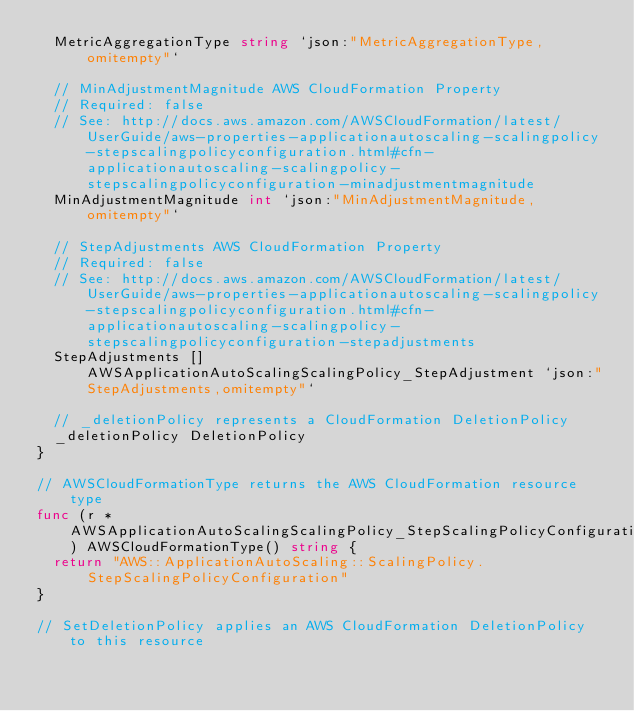<code> <loc_0><loc_0><loc_500><loc_500><_Go_>	MetricAggregationType string `json:"MetricAggregationType,omitempty"`

	// MinAdjustmentMagnitude AWS CloudFormation Property
	// Required: false
	// See: http://docs.aws.amazon.com/AWSCloudFormation/latest/UserGuide/aws-properties-applicationautoscaling-scalingpolicy-stepscalingpolicyconfiguration.html#cfn-applicationautoscaling-scalingpolicy-stepscalingpolicyconfiguration-minadjustmentmagnitude
	MinAdjustmentMagnitude int `json:"MinAdjustmentMagnitude,omitempty"`

	// StepAdjustments AWS CloudFormation Property
	// Required: false
	// See: http://docs.aws.amazon.com/AWSCloudFormation/latest/UserGuide/aws-properties-applicationautoscaling-scalingpolicy-stepscalingpolicyconfiguration.html#cfn-applicationautoscaling-scalingpolicy-stepscalingpolicyconfiguration-stepadjustments
	StepAdjustments []AWSApplicationAutoScalingScalingPolicy_StepAdjustment `json:"StepAdjustments,omitempty"`

	// _deletionPolicy represents a CloudFormation DeletionPolicy
	_deletionPolicy DeletionPolicy
}

// AWSCloudFormationType returns the AWS CloudFormation resource type
func (r *AWSApplicationAutoScalingScalingPolicy_StepScalingPolicyConfiguration) AWSCloudFormationType() string {
	return "AWS::ApplicationAutoScaling::ScalingPolicy.StepScalingPolicyConfiguration"
}

// SetDeletionPolicy applies an AWS CloudFormation DeletionPolicy to this resource</code> 